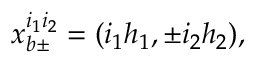Convert formula to latex. <formula><loc_0><loc_0><loc_500><loc_500>x _ { b \pm } ^ { i _ { 1 } i _ { 2 } } = ( i _ { 1 } h _ { 1 } , \pm i _ { 2 } h _ { 2 } ) ,</formula> 